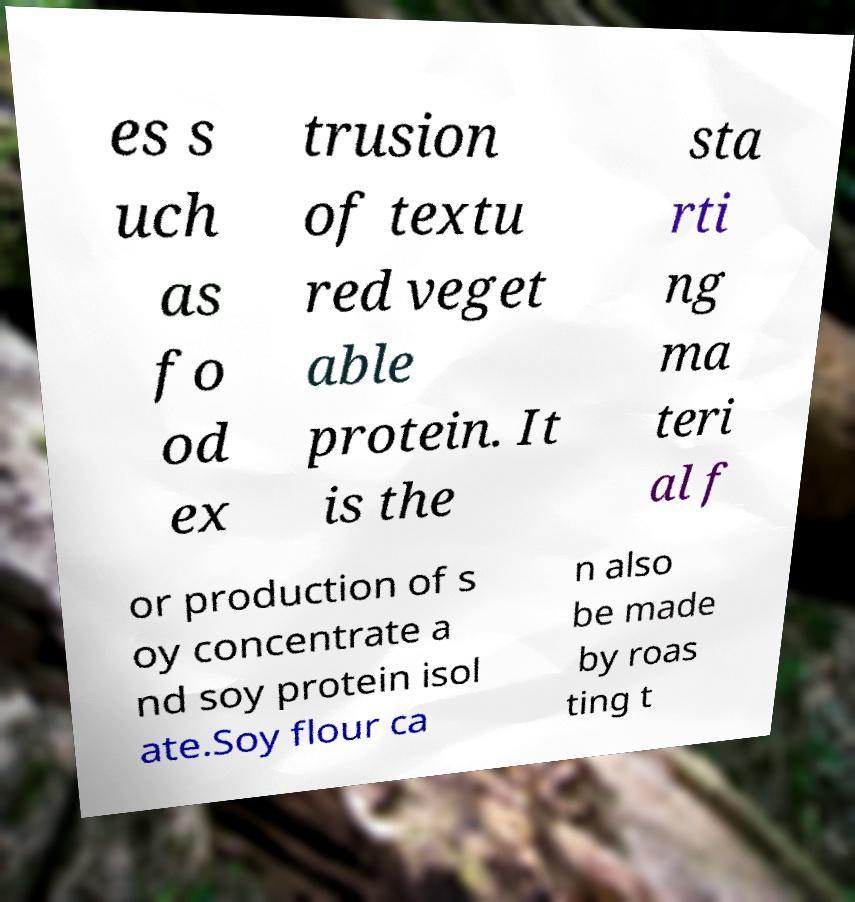What messages or text are displayed in this image? I need them in a readable, typed format. es s uch as fo od ex trusion of textu red veget able protein. It is the sta rti ng ma teri al f or production of s oy concentrate a nd soy protein isol ate.Soy flour ca n also be made by roas ting t 